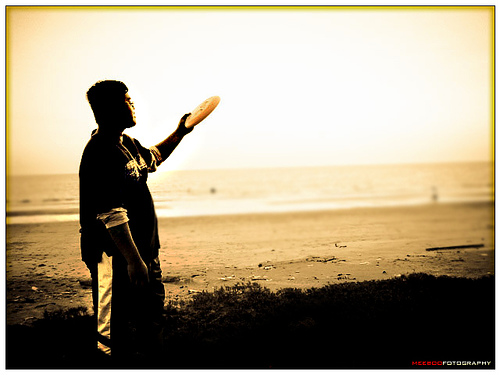<image>Was this picture taken on a west coast? It is uncertain whether this picture was taken on a west coast. The location could be anywhere. Was this picture taken on a west coast? I don't know if this picture was taken on a west coast. It is uncertain. 